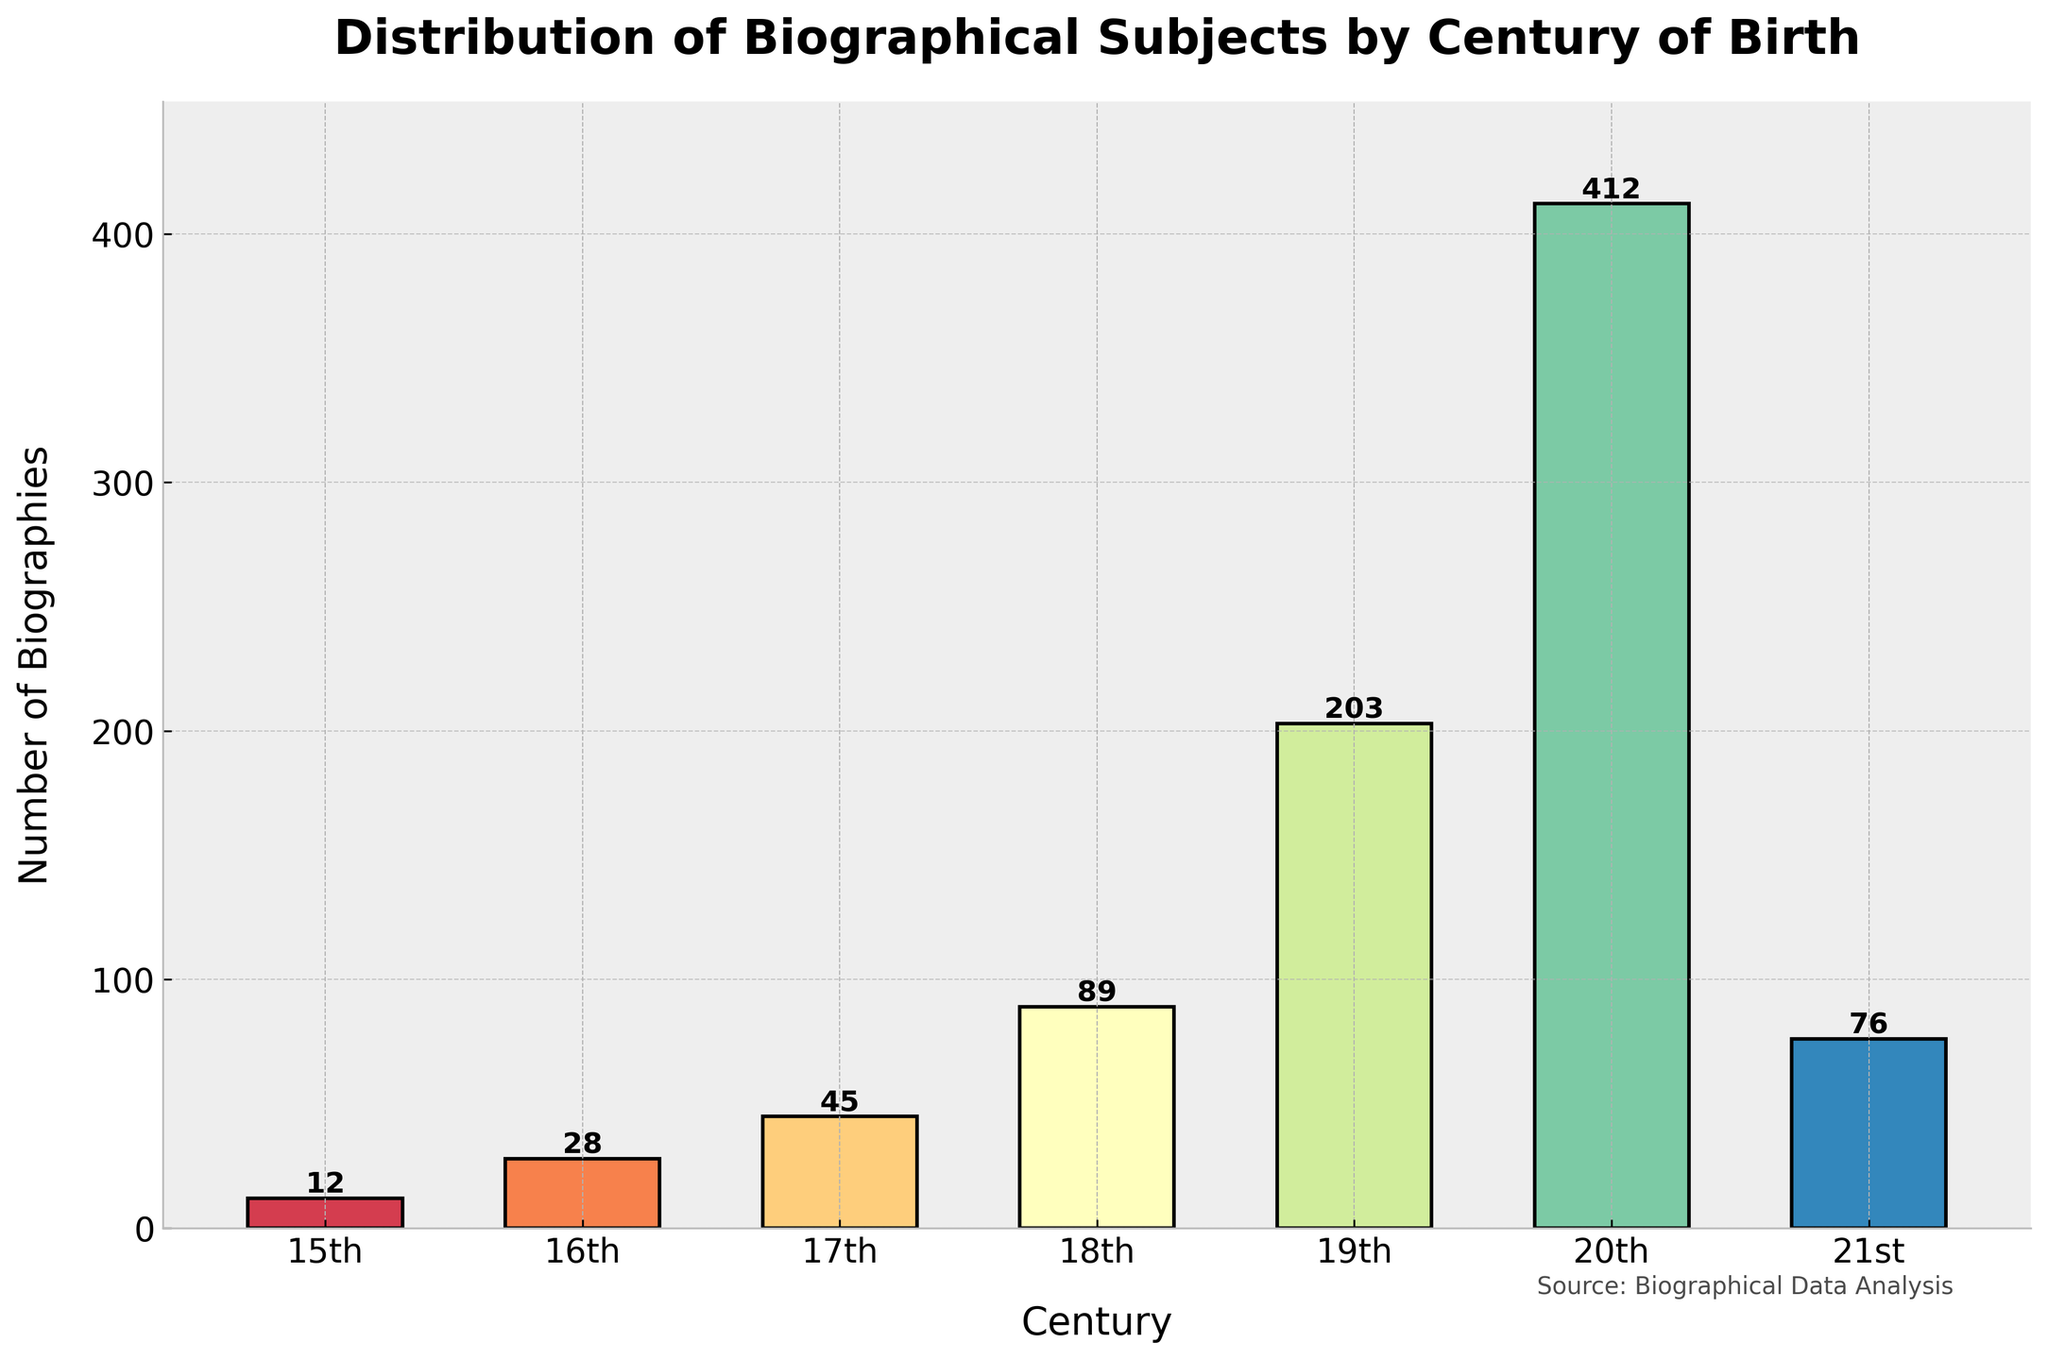Which century has the highest number of biographies? To determine this, look at the heights of the bars and identify which bar reaches the highest point. The bar for the 20th century is the tallest, indicating it has the highest number of biographies.
Answer: 20th century Which century has the fewest number of biographies? Look for the shortest bar in the chart. The bar for the 15th century is the shortest, indicating it has the fewest number of biographies.
Answer: 15th century What is the total number of biographies from the 18th and 19th centuries? Sum the heights of the bars for the 18th and 19th centuries. The 18th century has 89 biographies, and the 19th century has 203 biographies. Therefore, 89 + 203 = 292.
Answer: 292 How does the number of biographies in the 21st century compare to the 17th century? Compare the heights of the bars for the 21st and the 17th centuries. The 21st century has 76 biographies, whereas the 17th century has 45 biographies. Since 76 > 45, the 21st century has more biographies than the 17th century.
Answer: The 21st century has more What is the average number of biographies per century? First, sum the total number of biographies from all centuries: 12 + 28 + 45 + 89 + 203 + 412 + 76 = 865. Then, divide by the number of centuries, which is 7: 865 / 7 ≈ 123.57.
Answer: ~123.57 What is the difference in the number of biographies between the 20th and 21st centuries? Subtract the number of biographies in the 21st century from that of the 20th century. The 20th century has 412 biographies, and the 21st century has 76. Therefore, 412 - 76 = 336.
Answer: 336 Which century saw a greater increase in biographies compared to the previous one: the 18th to 19th or the 19th to 20th? Calculate the difference for both intervals. From the 18th (89) to the 19th (203) is 203 - 89 = 114. From the 19th (203) to the 20th (412) is 412 - 203 = 209. Compare 114 and 209; 209 is greater.
Answer: 19th to 20th Between which centuries is the greatest decrease in the number of biographies observed? Examine the differences between each pair of consecutive centuries. The decrease from the 20th century (412) to the 21st century (76) is 412 - 76 = 336, which is the largest decrease.
Answer: 20th to 21st What percentage of the total number of biographies does the 20th century contribute? First, find the total number of biographies: 865. Then, calculate the percentage contribution of the 20th century by dividing its value by the total and multiplying by 100: (412 / 865) * 100 ≈ 47.63%.
Answer: ~47.63% What is the sum of the number of biographies from the 16th, 17th, and 18th centuries? Add the number of biographies in these three centuries: 28 (16th) + 45 (17th) + 89 (18th) = 162.
Answer: 162 